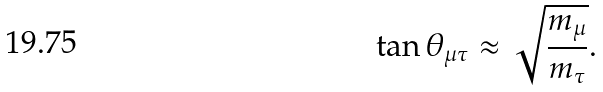<formula> <loc_0><loc_0><loc_500><loc_500>\tan \theta _ { \mu \tau } \approx \sqrt { \frac { m _ { \mu } } { m _ { \tau } } } .</formula> 